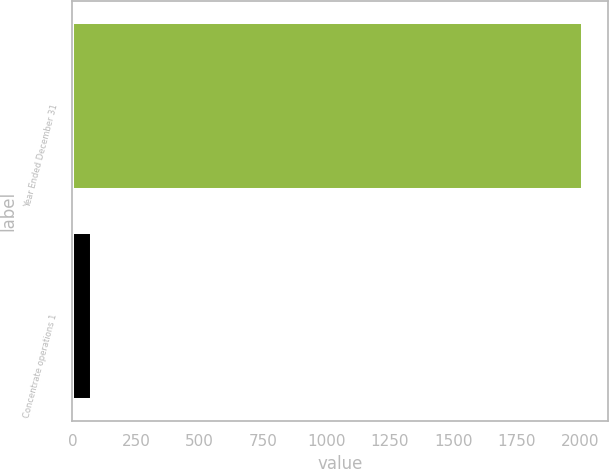Convert chart to OTSL. <chart><loc_0><loc_0><loc_500><loc_500><bar_chart><fcel>Year Ended December 31<fcel>Concentrate operations 1<nl><fcel>2009<fcel>78<nl></chart> 